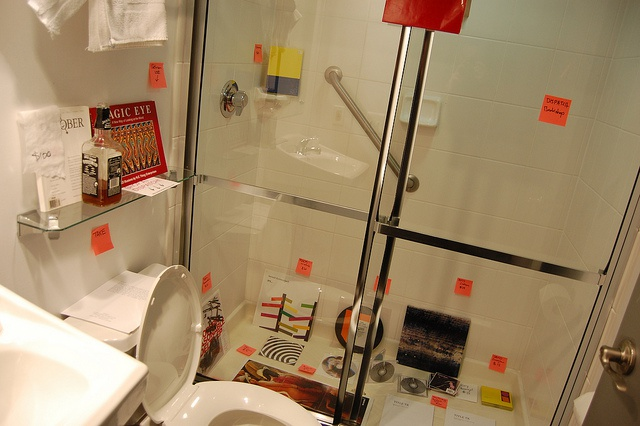Describe the objects in this image and their specific colors. I can see sink in tan and ivory tones, toilet in tan and gray tones, book in tan, maroon, and brown tones, book in tan and gray tones, and bottle in tan, maroon, black, and gray tones in this image. 